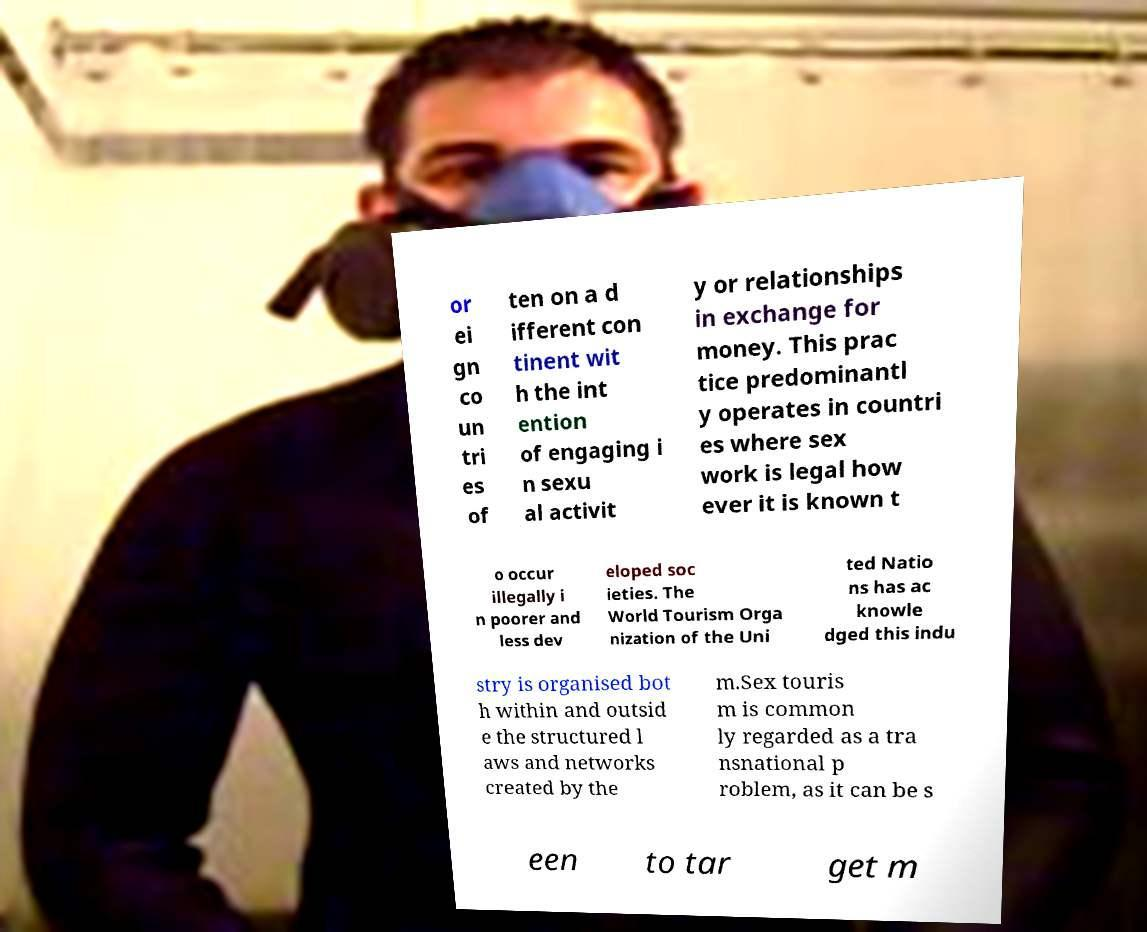Please identify and transcribe the text found in this image. or ei gn co un tri es of ten on a d ifferent con tinent wit h the int ention of engaging i n sexu al activit y or relationships in exchange for money. This prac tice predominantl y operates in countri es where sex work is legal how ever it is known t o occur illegally i n poorer and less dev eloped soc ieties. The World Tourism Orga nization of the Uni ted Natio ns has ac knowle dged this indu stry is organised bot h within and outsid e the structured l aws and networks created by the m.Sex touris m is common ly regarded as a tra nsnational p roblem, as it can be s een to tar get m 